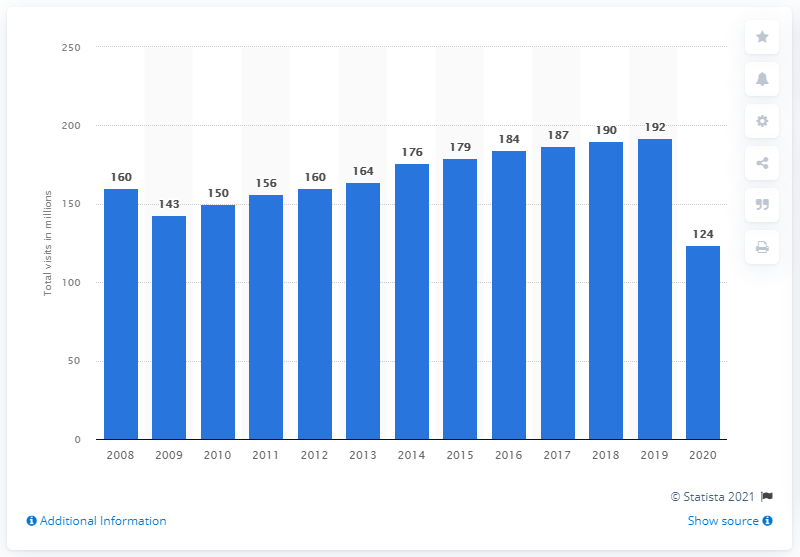Identify some key points in this picture. In 2020, the U.S. spa industry reported 124 visitors. 